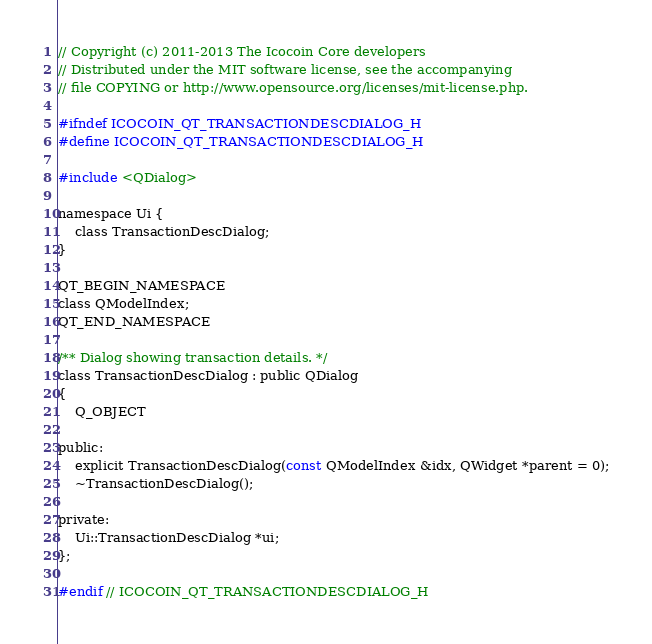Convert code to text. <code><loc_0><loc_0><loc_500><loc_500><_C_>// Copyright (c) 2011-2013 The Icocoin Core developers
// Distributed under the MIT software license, see the accompanying
// file COPYING or http://www.opensource.org/licenses/mit-license.php.

#ifndef ICOCOIN_QT_TRANSACTIONDESCDIALOG_H
#define ICOCOIN_QT_TRANSACTIONDESCDIALOG_H

#include <QDialog>

namespace Ui {
    class TransactionDescDialog;
}

QT_BEGIN_NAMESPACE
class QModelIndex;
QT_END_NAMESPACE

/** Dialog showing transaction details. */
class TransactionDescDialog : public QDialog
{
    Q_OBJECT

public:
    explicit TransactionDescDialog(const QModelIndex &idx, QWidget *parent = 0);
    ~TransactionDescDialog();

private:
    Ui::TransactionDescDialog *ui;
};

#endif // ICOCOIN_QT_TRANSACTIONDESCDIALOG_H
</code> 